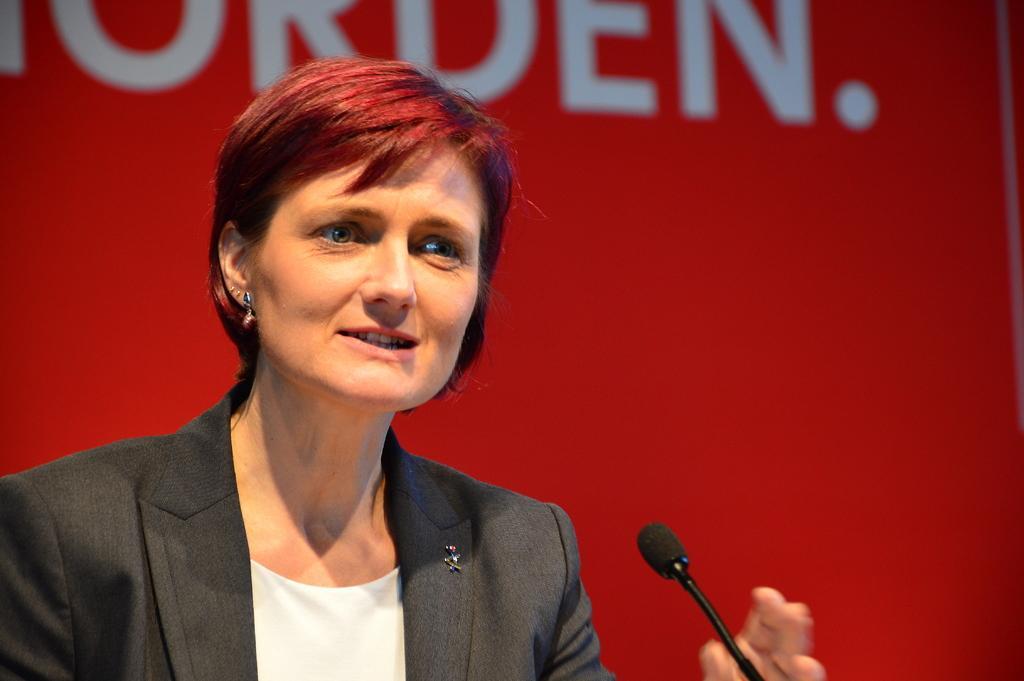Can you describe this image briefly? In this image we can see a person and a microphone. In the background of the image there is red background with a text. 